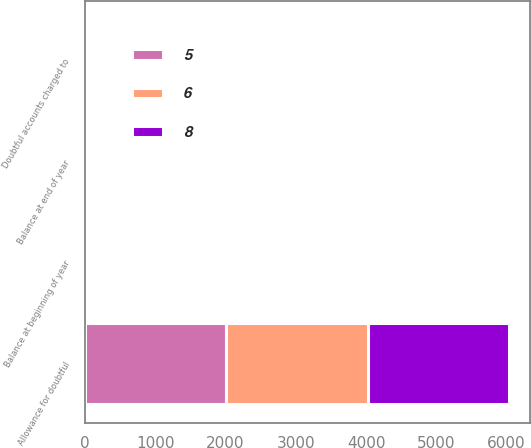<chart> <loc_0><loc_0><loc_500><loc_500><stacked_bar_chart><ecel><fcel>Allowance for doubtful<fcel>Balance at beginning of year<fcel>Doubtful accounts charged to<fcel>Balance at end of year<nl><fcel>8<fcel>2013<fcel>6<fcel>3<fcel>5<nl><fcel>6<fcel>2012<fcel>8<fcel>3<fcel>6<nl><fcel>5<fcel>2011<fcel>10<fcel>2<fcel>8<nl></chart> 